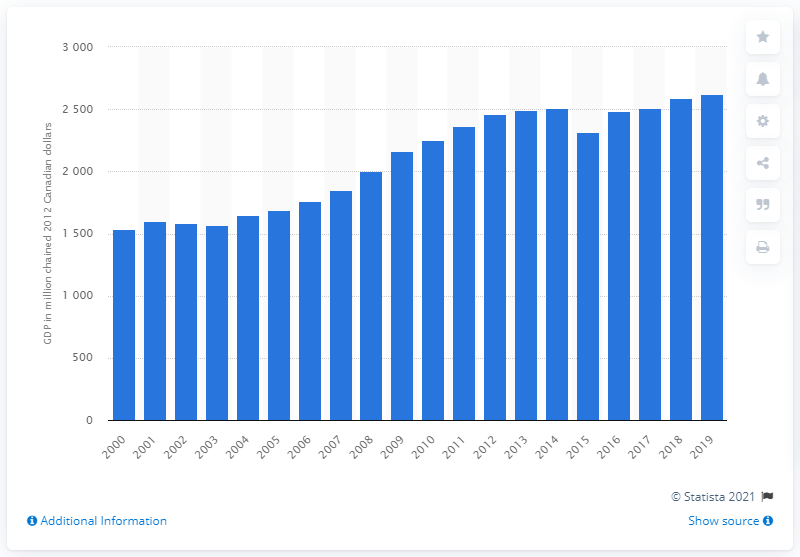Draw attention to some important aspects in this diagram. In 2012, the Gross Domestic Product (GDP) of Yukon was 2618.3 million Canadian dollars. 